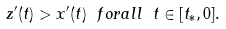Convert formula to latex. <formula><loc_0><loc_0><loc_500><loc_500>z ^ { \prime } ( t ) > x ^ { \prime } ( t ) \ f o r a l l \ t \in [ t _ { * } , 0 ] .</formula> 